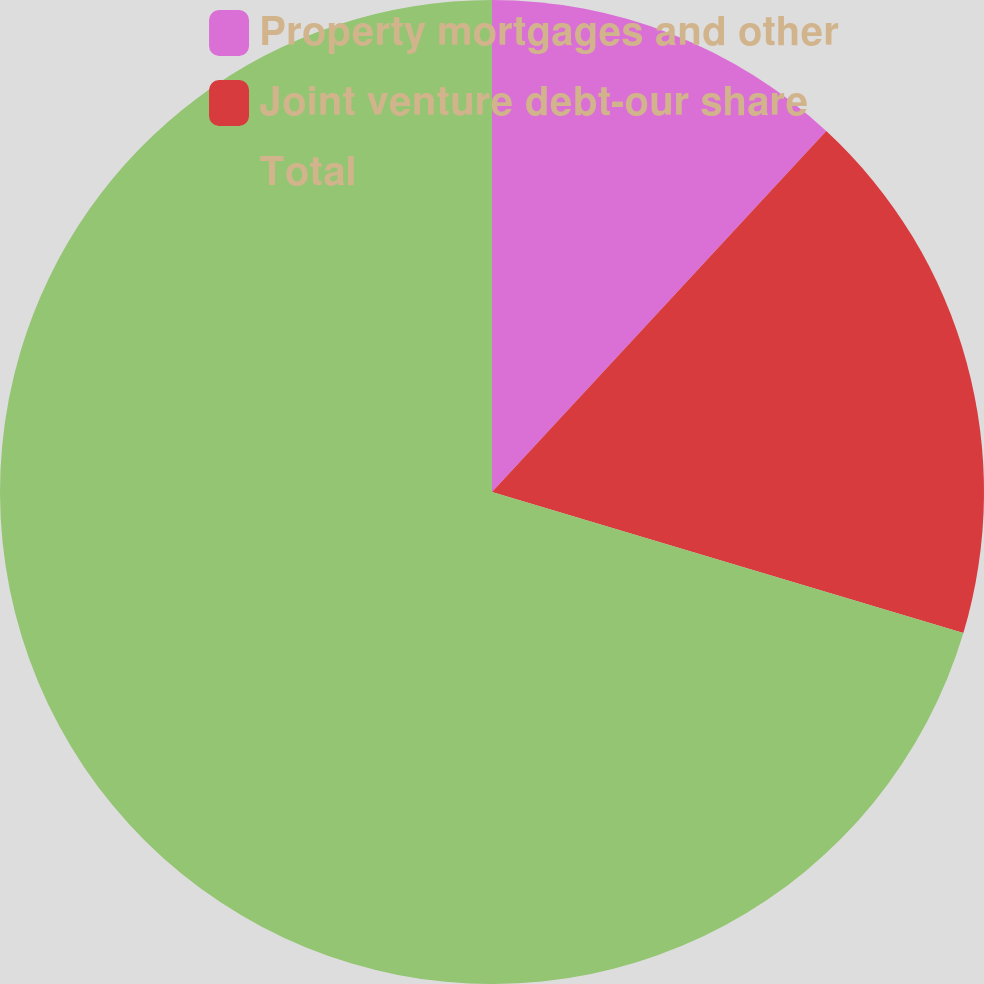Convert chart. <chart><loc_0><loc_0><loc_500><loc_500><pie_chart><fcel>Property mortgages and other<fcel>Joint venture debt-our share<fcel>Total<nl><fcel>11.89%<fcel>17.74%<fcel>70.38%<nl></chart> 